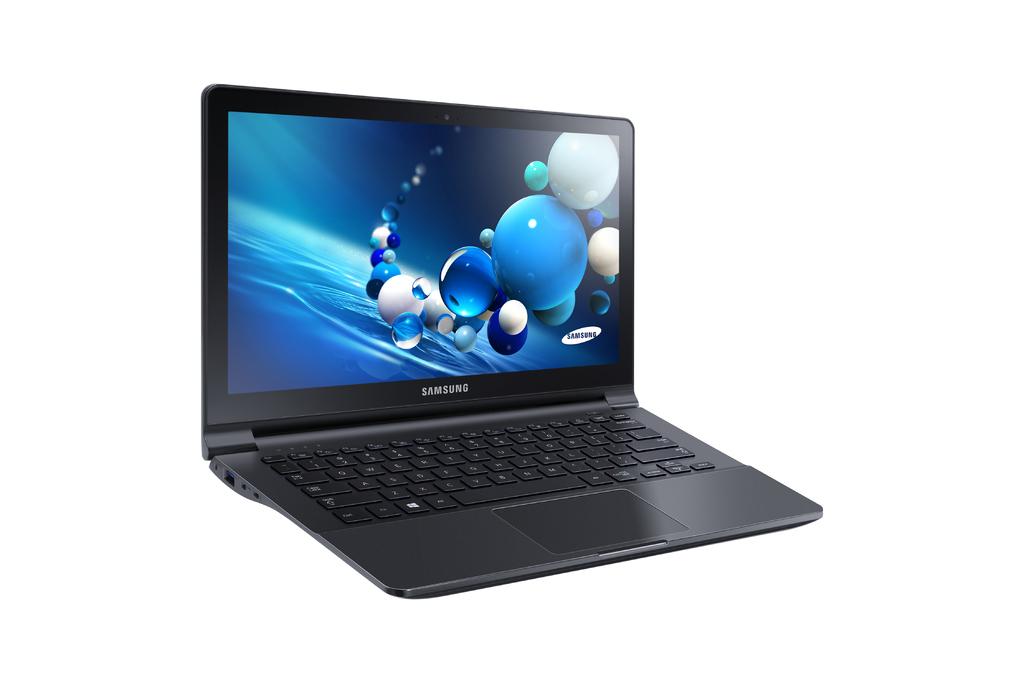What kind of laptop is this?
Offer a very short reply. Samsung. What company is this laptop from?
Provide a succinct answer. Samsung. 